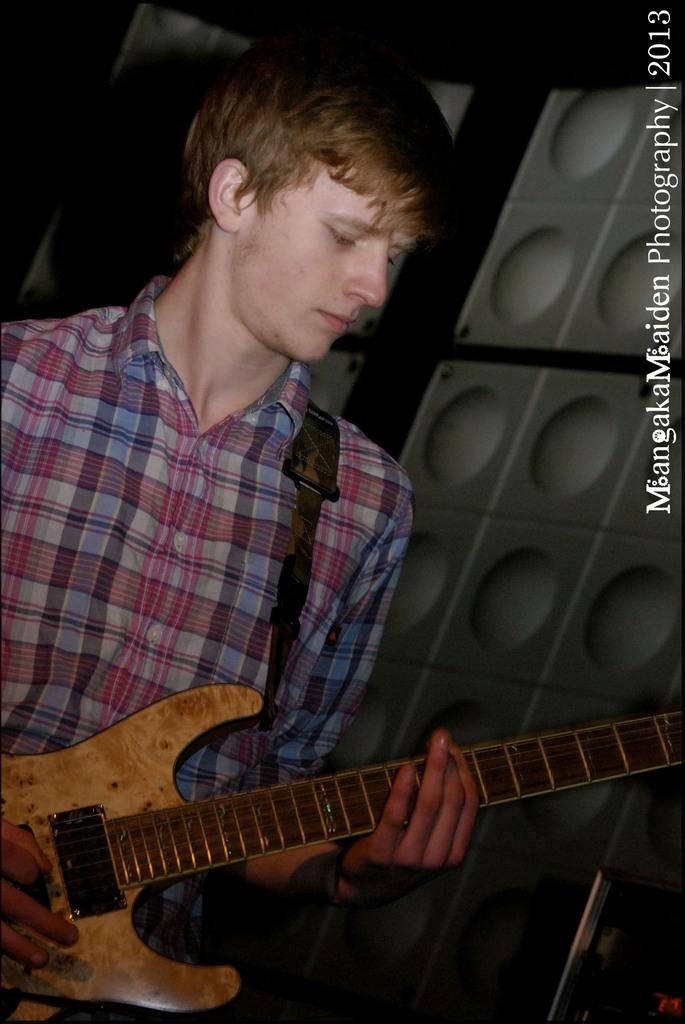Who is the main subject in the image? There is a boy in the image. Where is the boy positioned in the image? The boy is standing on the left side. What is the boy holding in the image? The boy is holding a yellow-colored music instrument. What can be seen in the background of the image? There is a white-colored wall in the background of the image. What type of treatment is the boy receiving in the image? There is no indication in the image that the boy is receiving any treatment. 